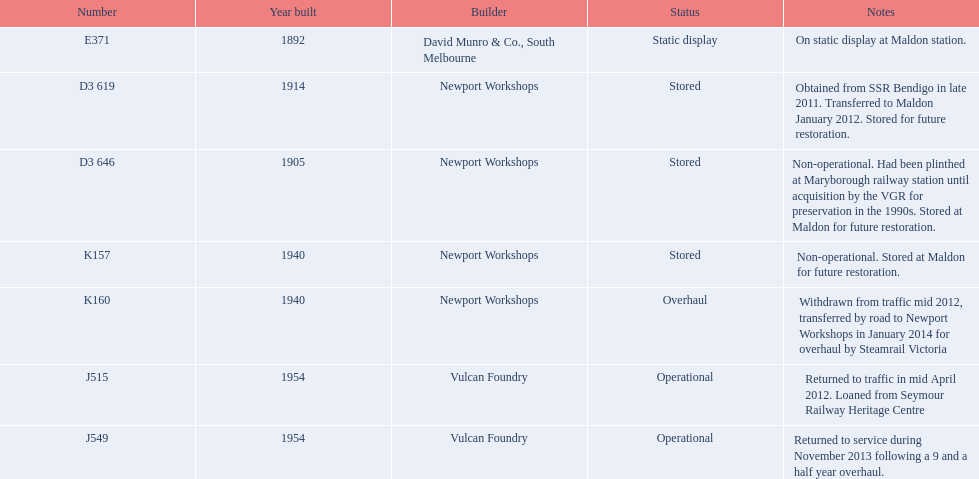Which trains are the only ones still in use? J515, J549. 